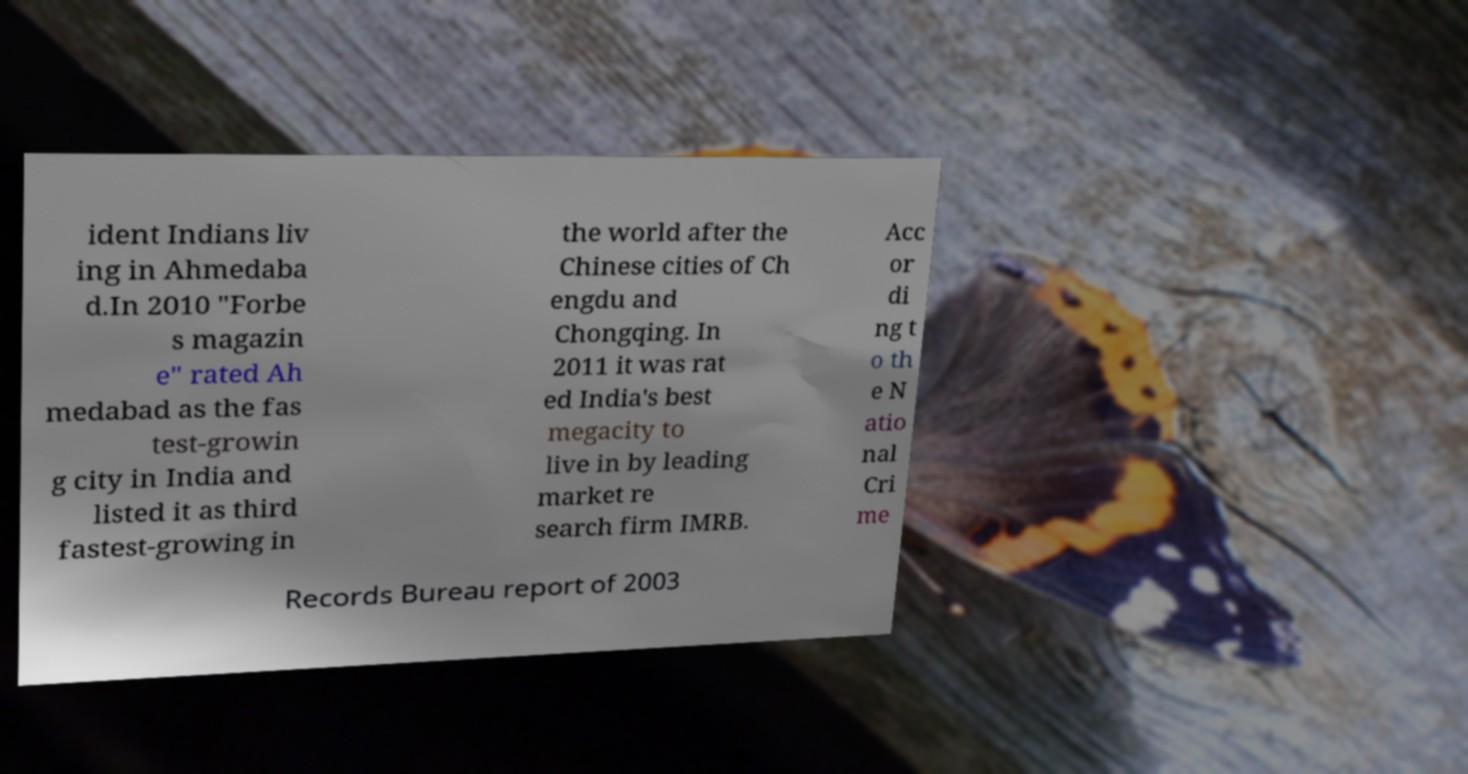Please read and relay the text visible in this image. What does it say? ident Indians liv ing in Ahmedaba d.In 2010 "Forbe s magazin e" rated Ah medabad as the fas test-growin g city in India and listed it as third fastest-growing in the world after the Chinese cities of Ch engdu and Chongqing. In 2011 it was rat ed India's best megacity to live in by leading market re search firm IMRB. Acc or di ng t o th e N atio nal Cri me Records Bureau report of 2003 